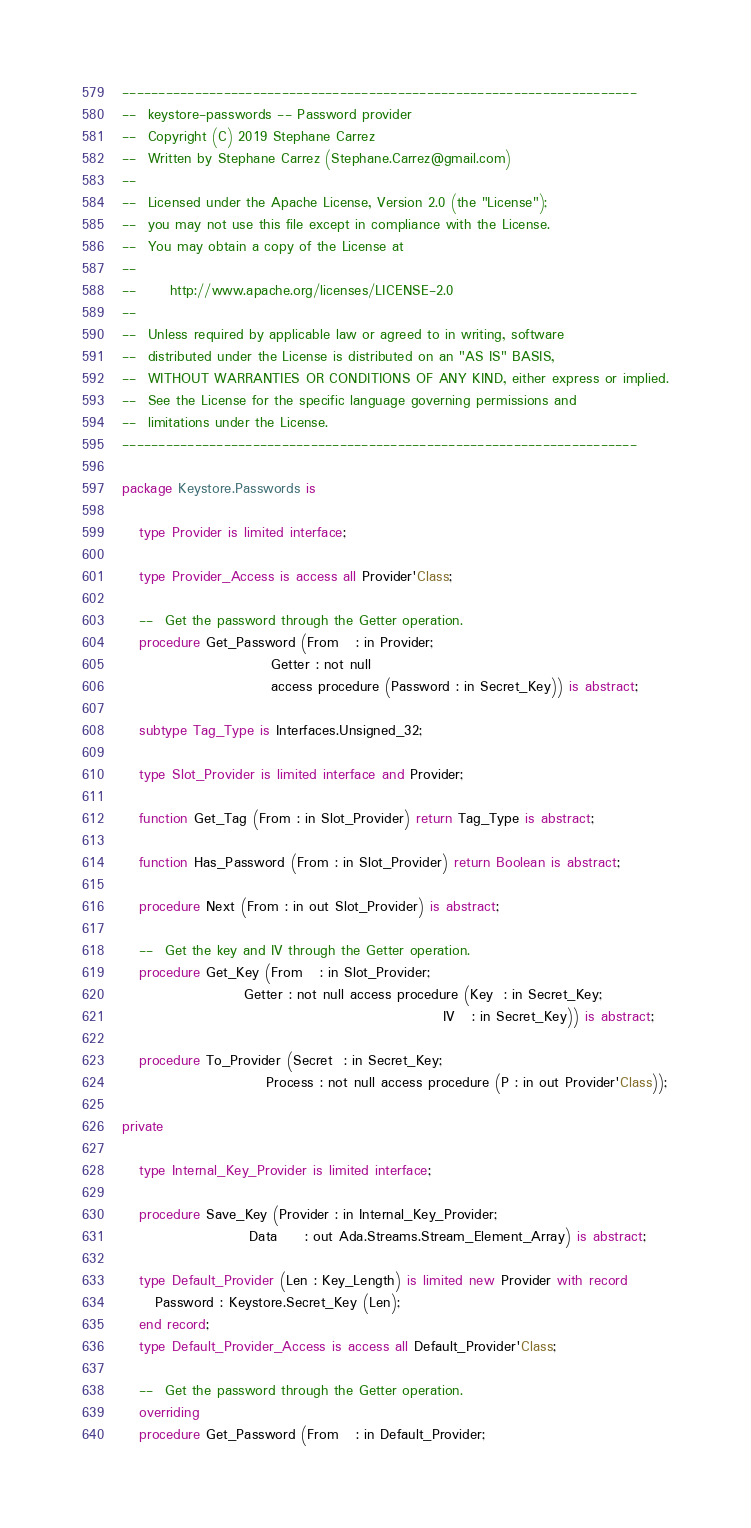<code> <loc_0><loc_0><loc_500><loc_500><_Ada_>-----------------------------------------------------------------------
--  keystore-passwords -- Password provider
--  Copyright (C) 2019 Stephane Carrez
--  Written by Stephane Carrez (Stephane.Carrez@gmail.com)
--
--  Licensed under the Apache License, Version 2.0 (the "License");
--  you may not use this file except in compliance with the License.
--  You may obtain a copy of the License at
--
--      http://www.apache.org/licenses/LICENSE-2.0
--
--  Unless required by applicable law or agreed to in writing, software
--  distributed under the License is distributed on an "AS IS" BASIS,
--  WITHOUT WARRANTIES OR CONDITIONS OF ANY KIND, either express or implied.
--  See the License for the specific language governing permissions and
--  limitations under the License.
-----------------------------------------------------------------------

package Keystore.Passwords is

   type Provider is limited interface;

   type Provider_Access is access all Provider'Class;

   --  Get the password through the Getter operation.
   procedure Get_Password (From   : in Provider;
                           Getter : not null
                           access procedure (Password : in Secret_Key)) is abstract;

   subtype Tag_Type is Interfaces.Unsigned_32;

   type Slot_Provider is limited interface and Provider;

   function Get_Tag (From : in Slot_Provider) return Tag_Type is abstract;

   function Has_Password (From : in Slot_Provider) return Boolean is abstract;

   procedure Next (From : in out Slot_Provider) is abstract;

   --  Get the key and IV through the Getter operation.
   procedure Get_Key (From   : in Slot_Provider;
                      Getter : not null access procedure (Key  : in Secret_Key;
                                                          IV   : in Secret_Key)) is abstract;

   procedure To_Provider (Secret  : in Secret_Key;
                          Process : not null access procedure (P : in out Provider'Class));

private

   type Internal_Key_Provider is limited interface;

   procedure Save_Key (Provider : in Internal_Key_Provider;
                       Data     : out Ada.Streams.Stream_Element_Array) is abstract;

   type Default_Provider (Len : Key_Length) is limited new Provider with record
      Password : Keystore.Secret_Key (Len);
   end record;
   type Default_Provider_Access is access all Default_Provider'Class;

   --  Get the password through the Getter operation.
   overriding
   procedure Get_Password (From   : in Default_Provider;</code> 